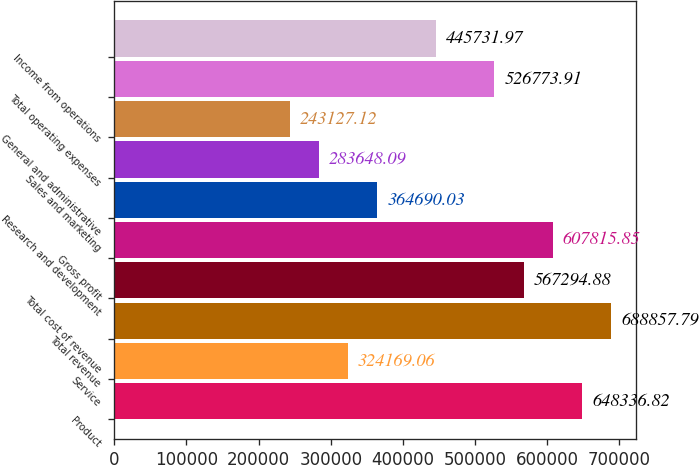<chart> <loc_0><loc_0><loc_500><loc_500><bar_chart><fcel>Product<fcel>Service<fcel>Total revenue<fcel>Total cost of revenue<fcel>Gross profit<fcel>Research and development<fcel>Sales and marketing<fcel>General and administrative<fcel>Total operating expenses<fcel>Income from operations<nl><fcel>648337<fcel>324169<fcel>688858<fcel>567295<fcel>607816<fcel>364690<fcel>283648<fcel>243127<fcel>526774<fcel>445732<nl></chart> 